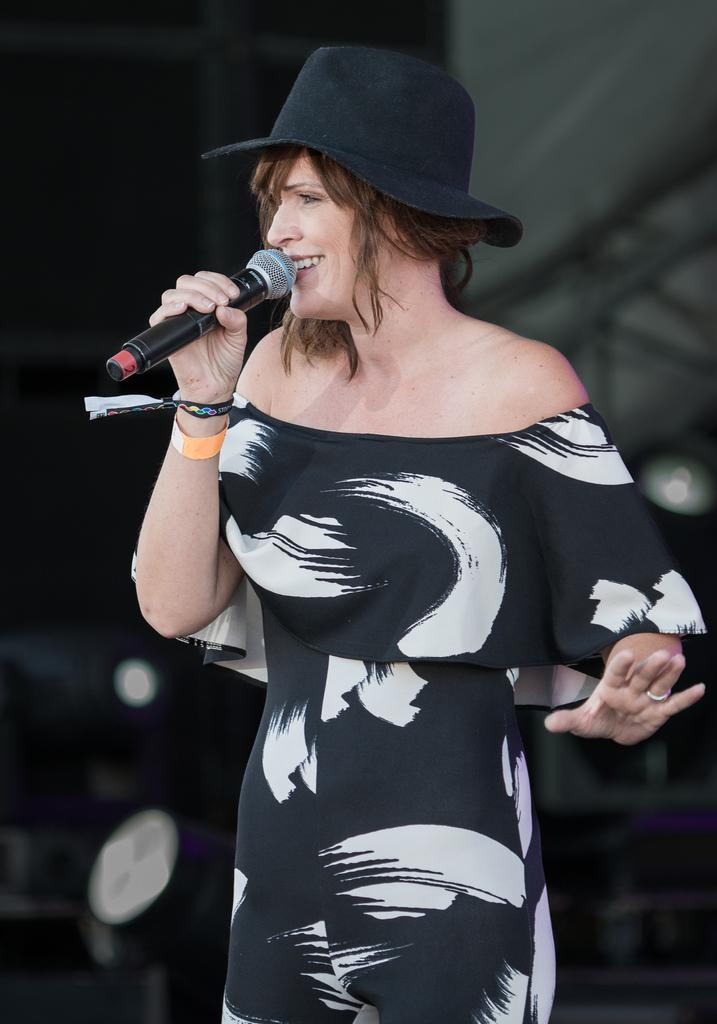What is the main subject of the image? The main subject of the image is a woman. What is the woman holding in the image? The woman is holding a microphone. What expression does the woman have in the image? The woman is smiling in the image. What type of headwear is the woman wearing in the image? The woman is wearing a cap in the image. What direction is the woman facing in the image? The provided facts do not mention the direction the woman is facing. Is there a clock visible in the image? There is no mention of a clock in the provided facts. 